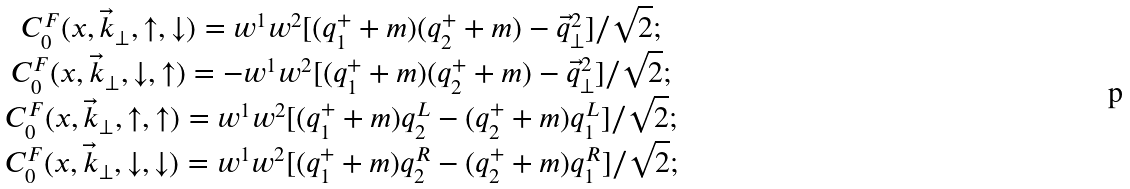Convert formula to latex. <formula><loc_0><loc_0><loc_500><loc_500>\begin{array} { c l c r } C ^ { F } _ { 0 } ( x , \vec { k } _ { \perp } , \uparrow , \downarrow ) = w ^ { 1 } w ^ { 2 } [ ( q _ { 1 } ^ { + } + m ) ( q _ { 2 } ^ { + } + m ) - \vec { q } ^ { 2 } _ { \perp } ] / \sqrt { 2 } ; \\ C ^ { F } _ { 0 } ( x , \vec { k } _ { \perp } , \downarrow , \uparrow ) = - w ^ { 1 } w ^ { 2 } [ ( q _ { 1 } ^ { + } + m ) ( q _ { 2 } ^ { + } + m ) - \vec { q } ^ { 2 } _ { \perp } ] / \sqrt { 2 } ; \\ C ^ { F } _ { 0 } ( x , \vec { k } _ { \perp } , \uparrow , \uparrow ) = w ^ { 1 } w ^ { 2 } [ ( q _ { 1 } ^ { + } + m ) q _ { 2 } ^ { L } - ( q _ { 2 } ^ { + } + m ) q _ { 1 } ^ { L } ] / \sqrt { 2 } ; \\ C ^ { F } _ { 0 } ( x , \vec { k } _ { \perp } , \downarrow , \downarrow ) = w ^ { 1 } w ^ { 2 } [ ( q _ { 1 } ^ { + } + m ) q _ { 2 } ^ { R } - ( q _ { 2 } ^ { + } + m ) q _ { 1 } ^ { R } ] / \sqrt { 2 } ; \\ \end{array}</formula> 